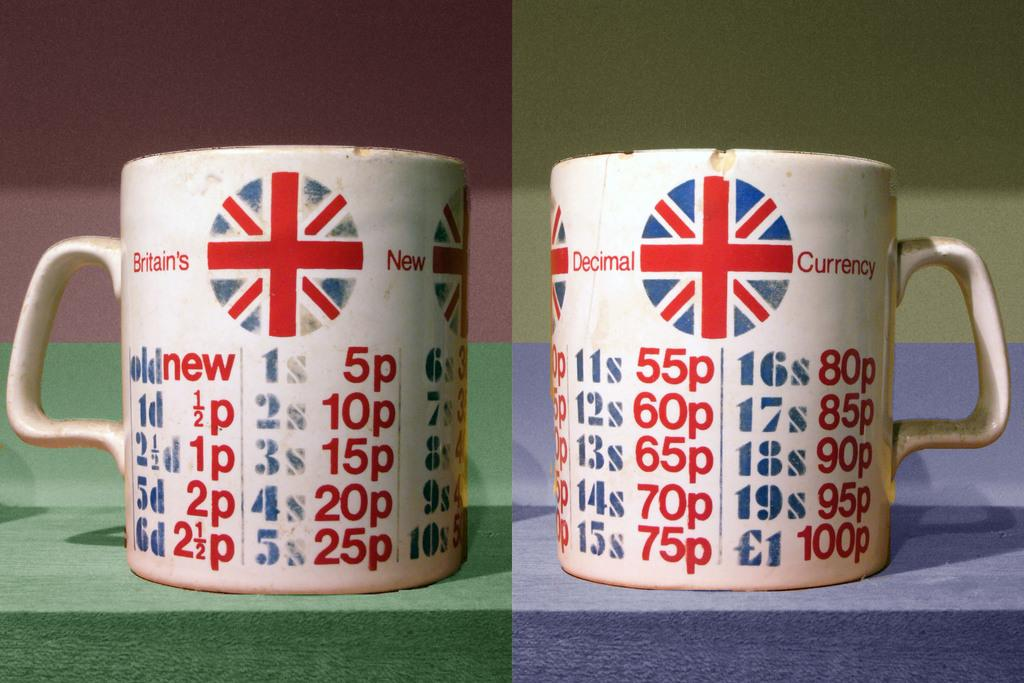What type of picture is in the image? There is a collage picture in the image. What objects are included in the collage picture? The collage picture contains cups. What can be seen on the cups in the image? The cups have a logo. What additional information is present on the cups? There is text written on the cups. What type of kitty can be seen interacting with the cups in the image? There is no kitty present in the image; the collage picture only contains cups with a logo and text. What is the texture of the cups in the image? The texture of the cups cannot be determined from the image alone, as it only provides visual information. 